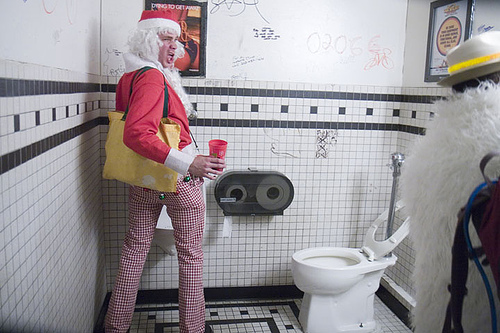Read and extract the text from this image. 0205 